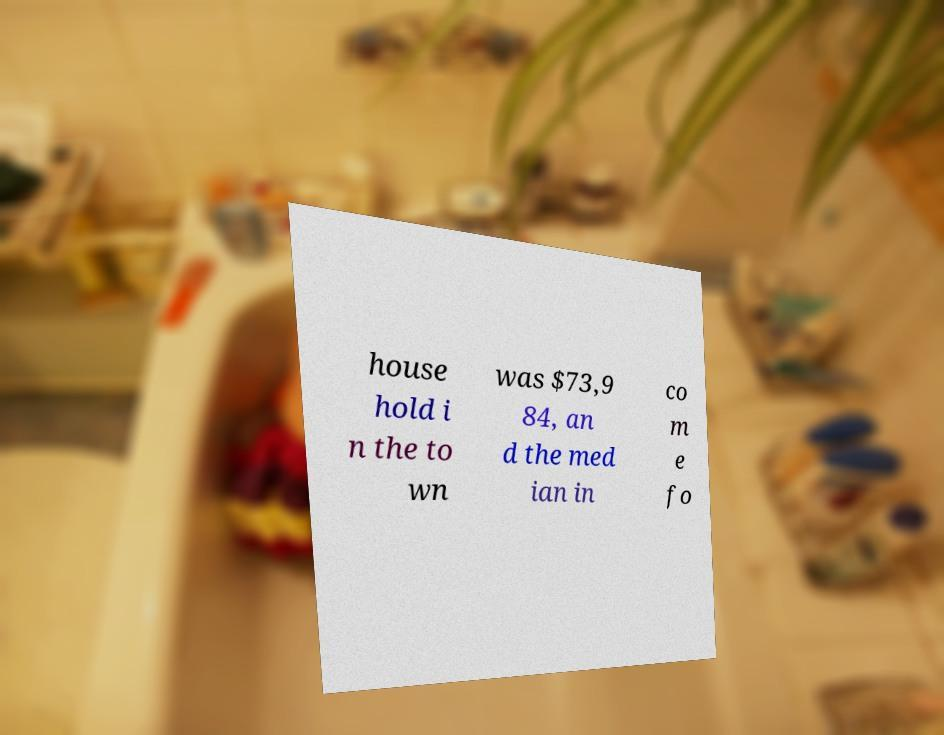There's text embedded in this image that I need extracted. Can you transcribe it verbatim? house hold i n the to wn was $73,9 84, an d the med ian in co m e fo 